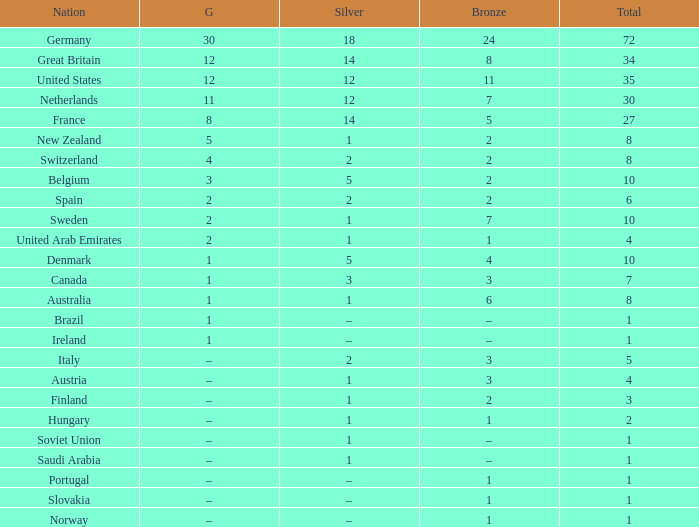What is the total number of Total, when Silver is 1, and when Bronze is 7? 1.0. 